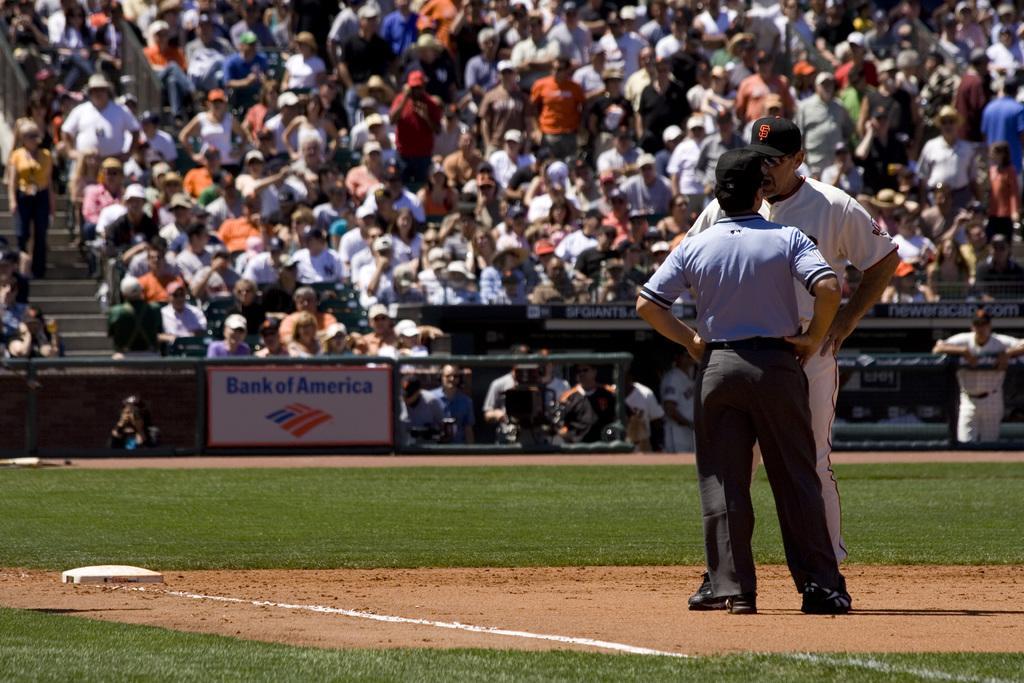How would you summarize this image in a sentence or two? On the right side of the image we can see two people standing. They are wearing caps. In the background there is crowd sitting and we can see a board. 